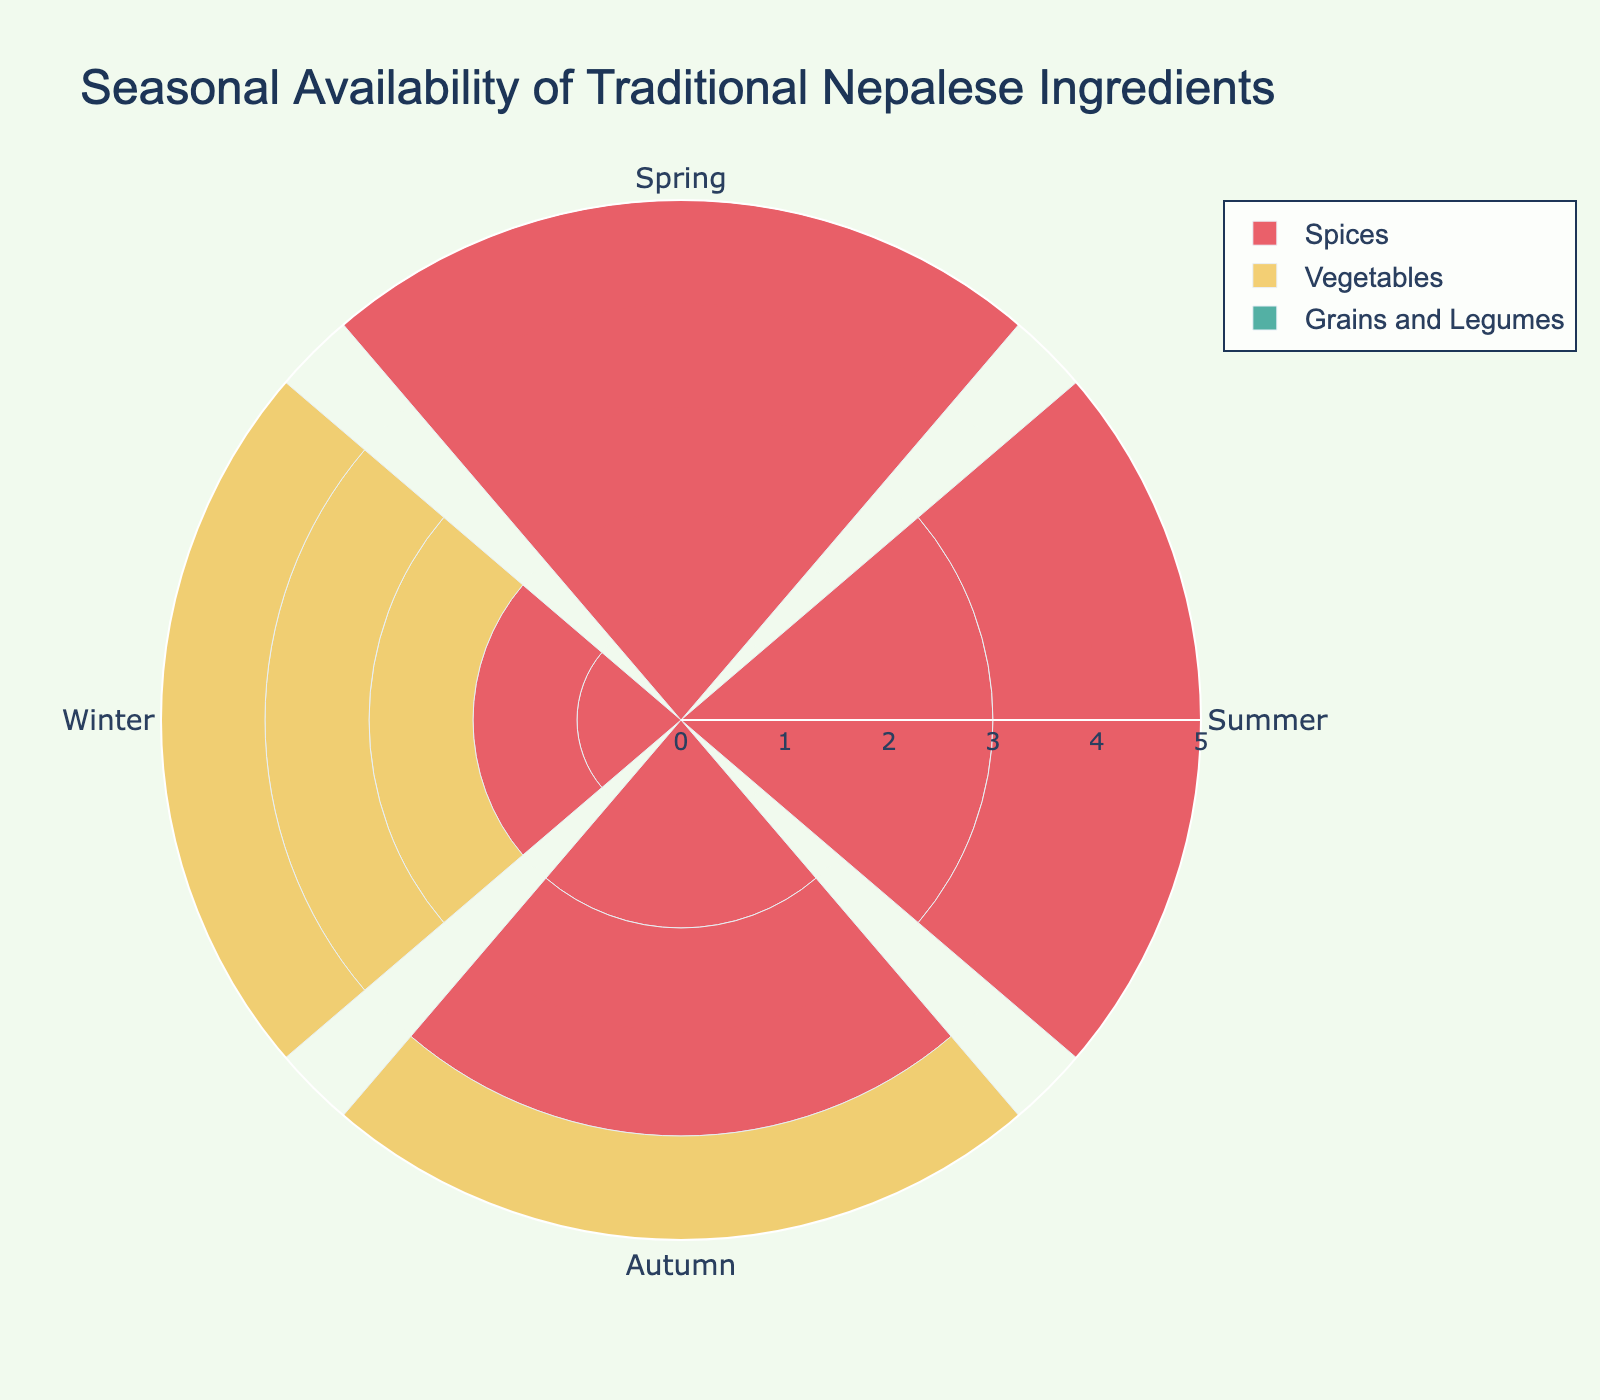Which category represents the highest seasonal availability in Spring? The category with the highest bar length in Spring is the one with the highest seasonal availability. Looking at the bars in the Spring section, "Spices" category has the highest value.
Answer: Spices During which season is " Tarul (Yam)" most available? Find the highest bar for "Tarul (Yam)" through the seasons. The maximum value for "Tarul (Yam)" is during Winter.
Answer: Winter Compare the seasonal availability of "Buckwheat" in Summer to "Tarul (Yam)" in Winter. Which has the higher value? Check the bar lengths for "Buckwheat" in Summer and "Tarul (Yam)" in Winter. "Buckwheat" in Summer is 5, while "Tarul (Yam)" in Winter is also 5.
Answer: Equal For the category "Vegetables," which season has the least availability? Look at the bar lengths for the "Vegetables" category across all seasons. The shortest bar is in Winter.
Answer: Winter What is the average seasonal availability of "Timur (Sichuan Pepper)" across all seasons? Sum the values of "Timur (Sichuan Pepper)" in all seasons and divide by the number of seasons. (5+3+2+1)/4 = 11/4 = 2.75
Answer: 2.75 Which ingredient has the greatest decrease in availability from Spring to Winter? Subtract the Winter values from the Spring values for each ingredient and identify the largest difference. "Asparagus" decreases the most from 4 in Spring to 1 in Winter, resulting in a difference of 3.
Answer: Asparagus How does "Jimbu (Herb)" compare to "Amla (Indian Gooseberry)" in Summer? Compare the bar lengths of both ingredients in the Summer season. "Jimbu (Herb)" has a value of 3, while "Amla (Indian Gooseberry)" also has a value of 3.
Answer: Equal 